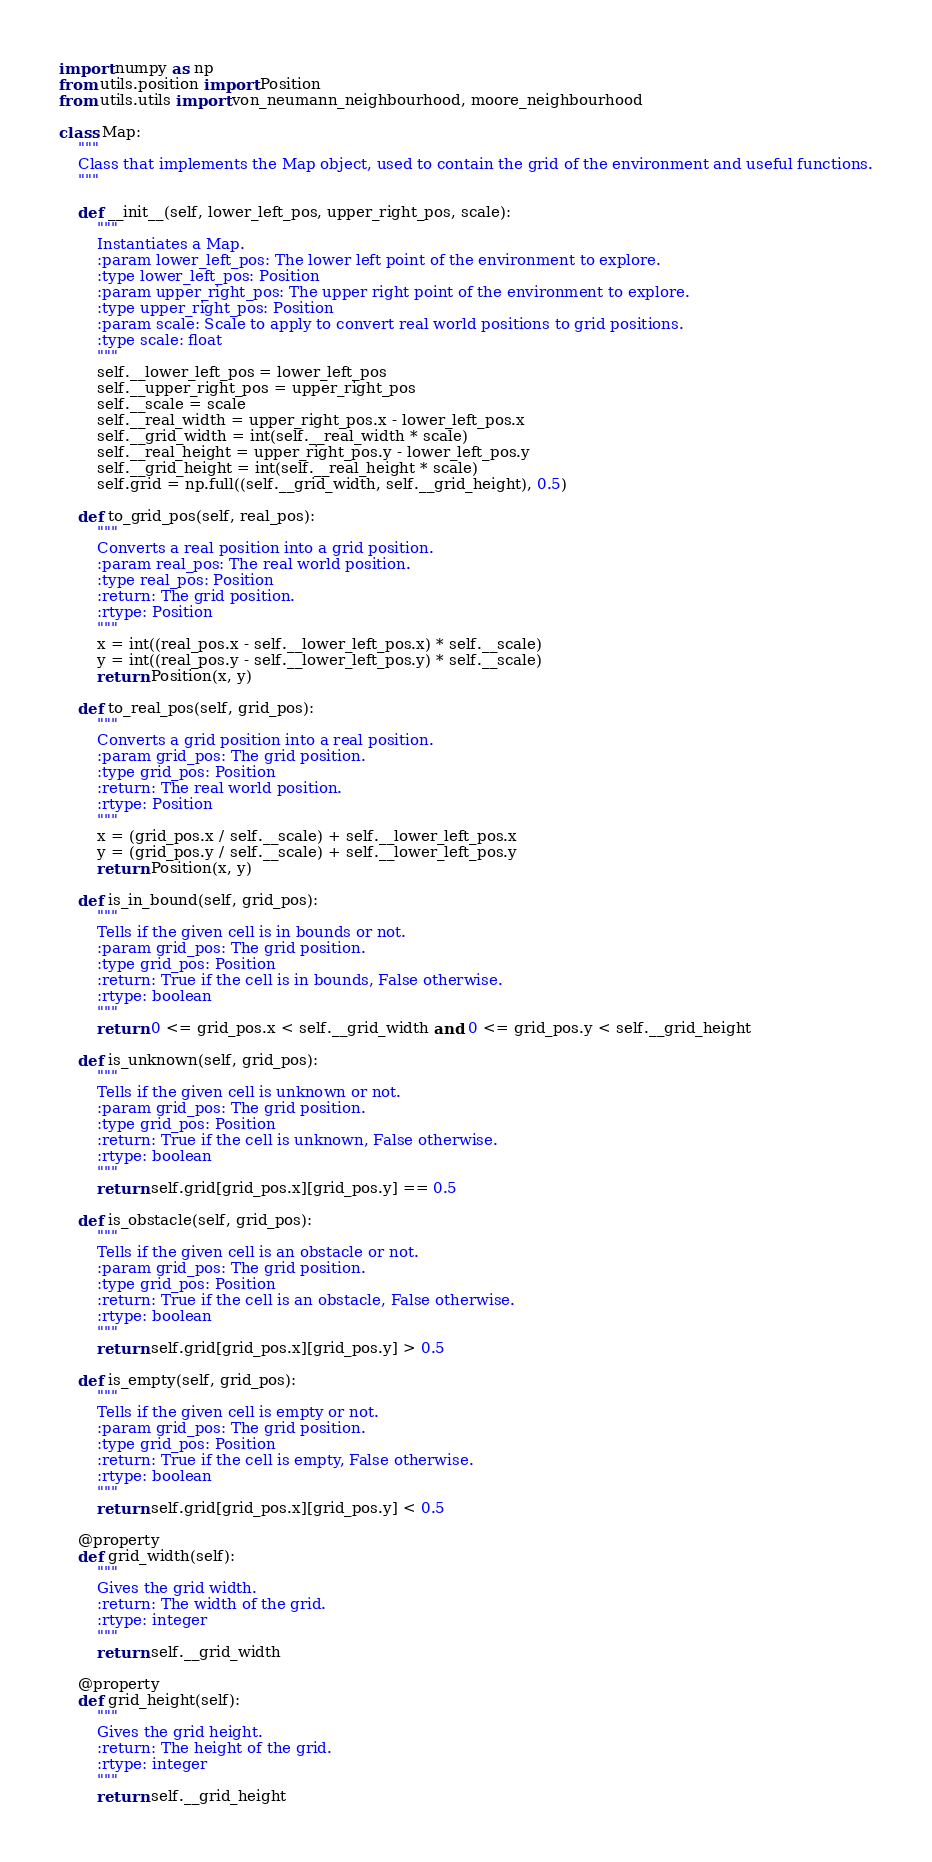Convert code to text. <code><loc_0><loc_0><loc_500><loc_500><_Python_>import numpy as np
from utils.position import Position
from utils.utils import von_neumann_neighbourhood, moore_neighbourhood

class Map:
    """
    Class that implements the Map object, used to contain the grid of the environment and useful functions.
    """

    def __init__(self, lower_left_pos, upper_right_pos, scale):
        """
        Instantiates a Map.
        :param lower_left_pos: The lower left point of the environment to explore.
        :type lower_left_pos: Position
        :param upper_right_pos: The upper right point of the environment to explore.
        :type upper_right_pos: Position
        :param scale: Scale to apply to convert real world positions to grid positions.
        :type scale: float
        """
        self.__lower_left_pos = lower_left_pos
        self.__upper_right_pos = upper_right_pos
        self.__scale = scale
        self.__real_width = upper_right_pos.x - lower_left_pos.x 
        self.__grid_width = int(self.__real_width * scale)
        self.__real_height = upper_right_pos.y - lower_left_pos.y 
        self.__grid_height = int(self.__real_height * scale)
        self.grid = np.full((self.__grid_width, self.__grid_height), 0.5)

    def to_grid_pos(self, real_pos):
        """
        Converts a real position into a grid position.
        :param real_pos: The real world position.
        :type real_pos: Position
        :return: The grid position.
        :rtype: Position
        """
        x = int((real_pos.x - self.__lower_left_pos.x) * self.__scale)
        y = int((real_pos.y - self.__lower_left_pos.y) * self.__scale)
        return Position(x, y)

    def to_real_pos(self, grid_pos):
        """
        Converts a grid position into a real position.
        :param grid_pos: The grid position.
        :type grid_pos: Position
        :return: The real world position.
        :rtype: Position
        """
        x = (grid_pos.x / self.__scale) + self.__lower_left_pos.x
        y = (grid_pos.y / self.__scale) + self.__lower_left_pos.y
        return Position(x, y)

    def is_in_bound(self, grid_pos):
        """
        Tells if the given cell is in bounds or not.
        :param grid_pos: The grid position.
        :type grid_pos: Position
        :return: True if the cell is in bounds, False otherwise.
        :rtype: boolean
        """
        return 0 <= grid_pos.x < self.__grid_width and 0 <= grid_pos.y < self.__grid_height

    def is_unknown(self, grid_pos):
        """
        Tells if the given cell is unknown or not.
        :param grid_pos: The grid position.
        :type grid_pos: Position
        :return: True if the cell is unknown, False otherwise.
        :rtype: boolean
        """
        return self.grid[grid_pos.x][grid_pos.y] == 0.5

    def is_obstacle(self, grid_pos):
        """
        Tells if the given cell is an obstacle or not.
        :param grid_pos: The grid position.
        :type grid_pos: Position
        :return: True if the cell is an obstacle, False otherwise.
        :rtype: boolean
        """
        return self.grid[grid_pos.x][grid_pos.y] > 0.5

    def is_empty(self, grid_pos):
        """
        Tells if the given cell is empty or not.
        :param grid_pos: The grid position.
        :type grid_pos: Position
        :return: True if the cell is empty, False otherwise.
        :rtype: boolean
        """
        return self.grid[grid_pos.x][grid_pos.y] < 0.5

    @property
    def grid_width(self):
        """
        Gives the grid width.
        :return: The width of the grid.
        :rtype: integer
        """
        return self.__grid_width

    @property
    def grid_height(self):
        """
        Gives the grid height.
        :return: The height of the grid.
        :rtype: integer
        """
        return self.__grid_height
</code> 